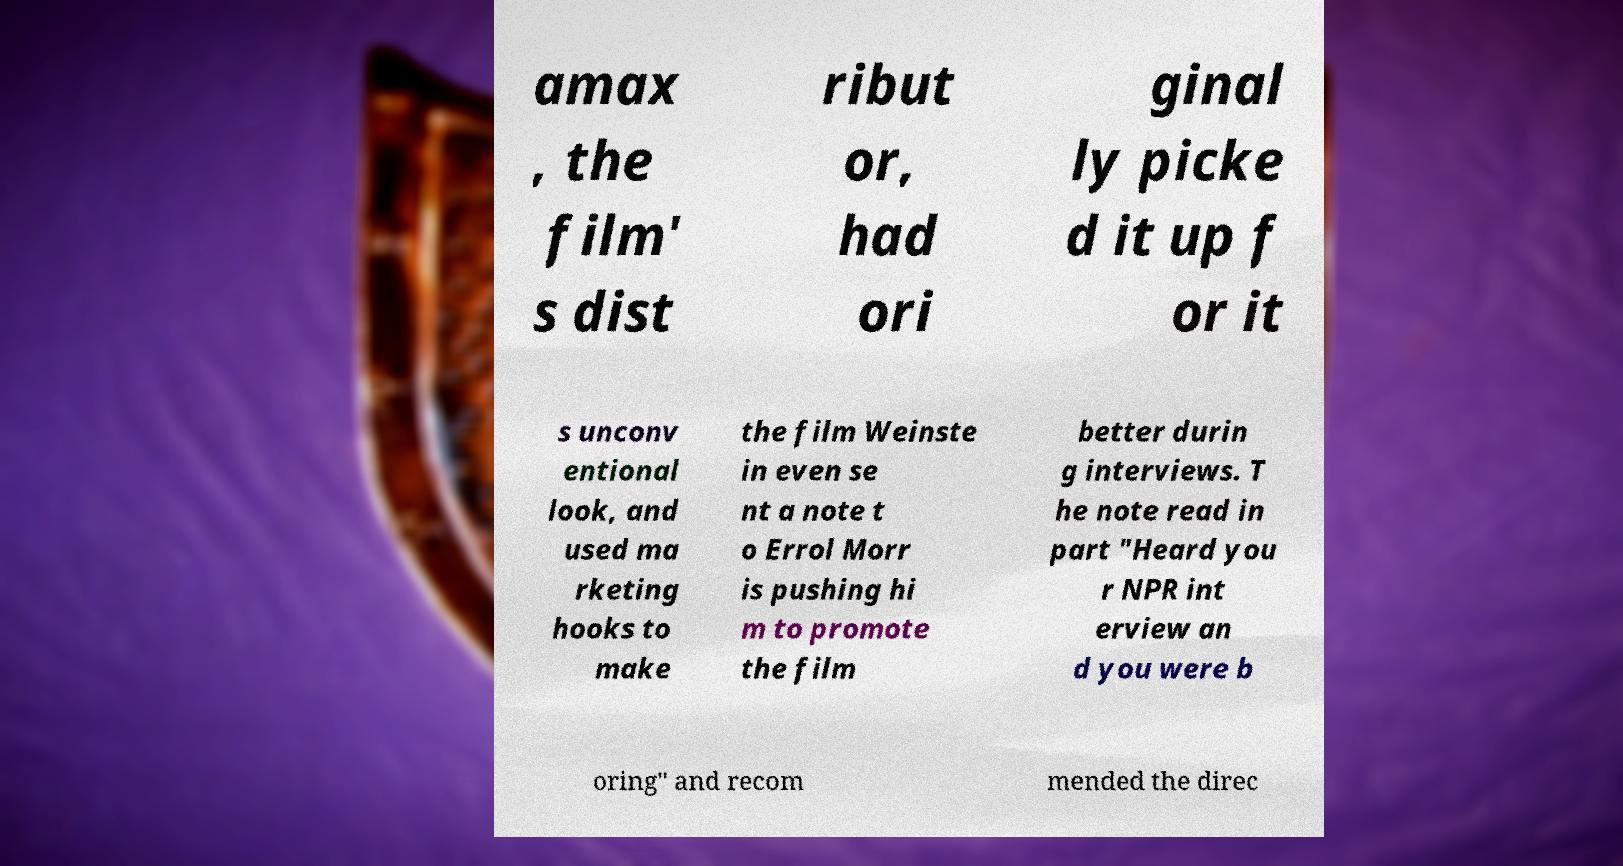There's text embedded in this image that I need extracted. Can you transcribe it verbatim? amax , the film' s dist ribut or, had ori ginal ly picke d it up f or it s unconv entional look, and used ma rketing hooks to make the film Weinste in even se nt a note t o Errol Morr is pushing hi m to promote the film better durin g interviews. T he note read in part "Heard you r NPR int erview an d you were b oring" and recom mended the direc 